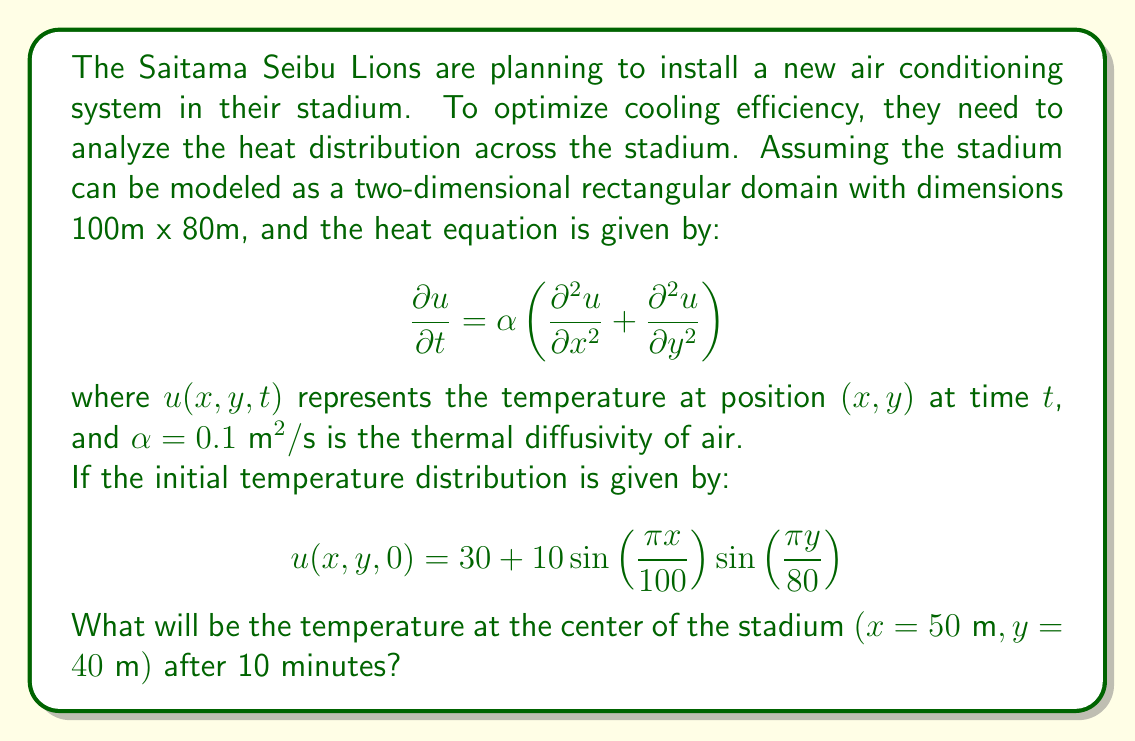Could you help me with this problem? To solve this problem, we need to use the method of separation of variables for the heat equation. Let's follow these steps:

1) We assume a solution of the form:
   $$ u(x,y,t) = X(x)Y(y)T(t) $$

2) Substituting this into the heat equation and separating variables, we get three ordinary differential equations:
   $$ \frac{d^2X}{dx^2} + \lambda^2X = 0 $$
   $$ \frac{d^2Y}{dy^2} + \mu^2Y = 0 $$
   $$ \frac{dT}{dt} + \alpha(\lambda^2 + \mu^2)T = 0 $$

3) Given the boundary conditions (which are implicitly zero at the edges of the stadium), we can determine the eigenfunctions:
   $$ X_n(x) = \sin\left(\frac{n\pi x}{100}\right), \quad n = 1,2,3,... $$
   $$ Y_m(y) = \sin\left(\frac{m\pi y}{80}\right), \quad m = 1,2,3,... $$

4) The time-dependent part of the solution is:
   $$ T_{nm}(t) = e^{-\alpha(\lambda_n^2 + \mu_m^2)t} $$
   where $\lambda_n = \frac{n\pi}{100}$ and $\mu_m = \frac{m\pi}{80}$

5) The general solution is:
   $$ u(x,y,t) = \sum_{n=1}^{\infty}\sum_{m=1}^{\infty} A_{nm}\sin\left(\frac{n\pi x}{100}\right)\sin\left(\frac{m\pi y}{80}\right)e^{-\alpha(\lambda_n^2 + \mu_m^2)t} $$

6) Comparing with the initial condition, we see that only the term with $n=m=1$ is non-zero, and $A_{11} = 10$. The constant term 30 can be added separately.

7) Therefore, the solution is:
   $$ u(x,y,t) = 30 + 10\sin\left(\frac{\pi x}{100}\right)\sin\left(\frac{\pi y}{80}\right)e^{-\alpha(\lambda_1^2 + \mu_1^2)t} $$

8) At the center of the stadium $(x=50\text{ m}, y=40\text{ m})$ after 10 minutes $(t=600\text{ s})$:
   $$ u(50,40,600) = 30 + 10\sin\left(\frac{\pi}{2}\right)\sin\left(\frac{\pi}{2}\right)e^{-0.1(\frac{\pi^2}{100^2} + \frac{\pi^2}{80^2})600} $$

9) Calculating:
   $$ u(50,40,600) = 30 + 10e^{-0.1(\frac{\pi^2}{100^2} + \frac{\pi^2}{80^2})600} \approx 30 + 10e^{-0.0577} \approx 39.44 $$
Answer: The temperature at the center of the stadium after 10 minutes will be approximately 39.44°C. 